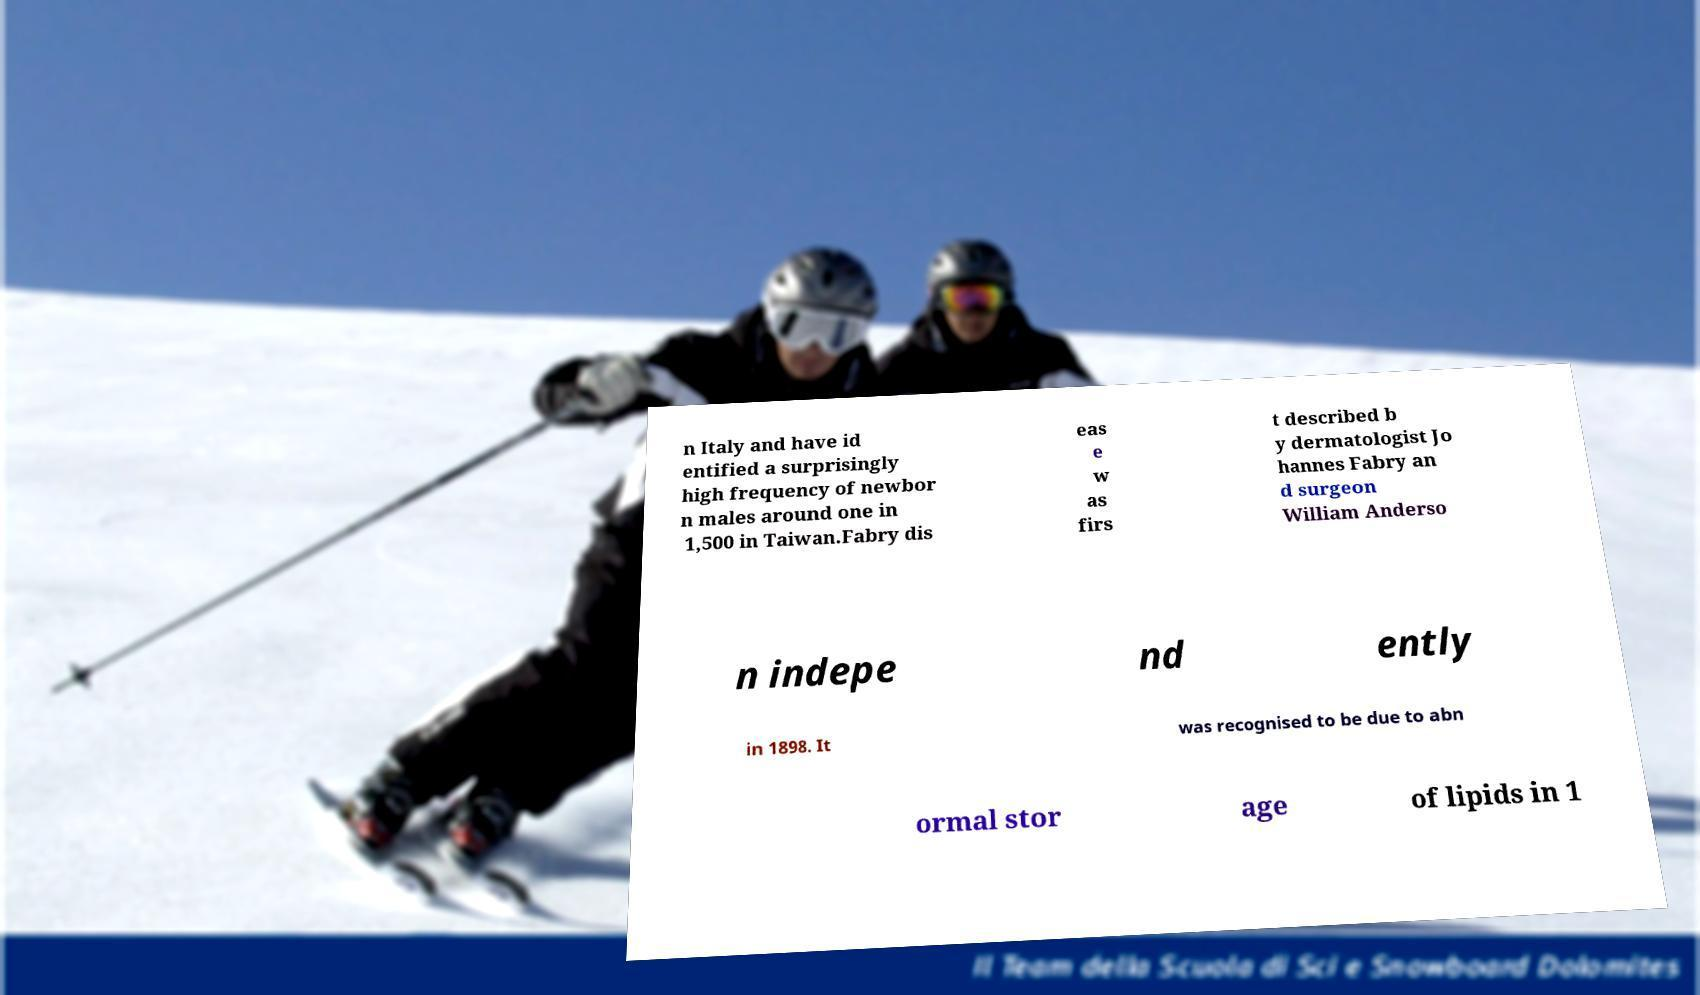Can you accurately transcribe the text from the provided image for me? n Italy and have id entified a surprisingly high frequency of newbor n males around one in 1,500 in Taiwan.Fabry dis eas e w as firs t described b y dermatologist Jo hannes Fabry an d surgeon William Anderso n indepe nd ently in 1898. It was recognised to be due to abn ormal stor age of lipids in 1 